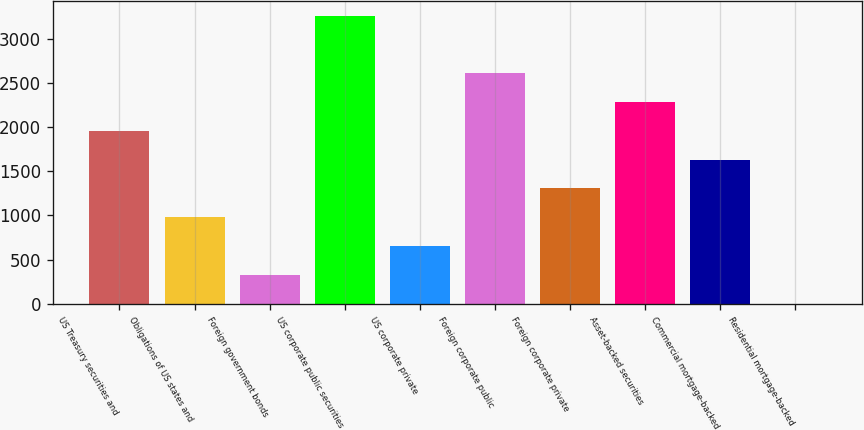Convert chart to OTSL. <chart><loc_0><loc_0><loc_500><loc_500><bar_chart><fcel>US Treasury securities and<fcel>Obligations of US states and<fcel>Foreign government bonds<fcel>US corporate public securities<fcel>US corporate private<fcel>Foreign corporate public<fcel>Foreign corporate private<fcel>Asset-backed securities<fcel>Commercial mortgage-backed<fcel>Residential mortgage-backed<nl><fcel>1958.07<fcel>979.36<fcel>326.88<fcel>3263.02<fcel>653.12<fcel>2610.54<fcel>1305.6<fcel>2284.3<fcel>1631.84<fcel>0.65<nl></chart> 